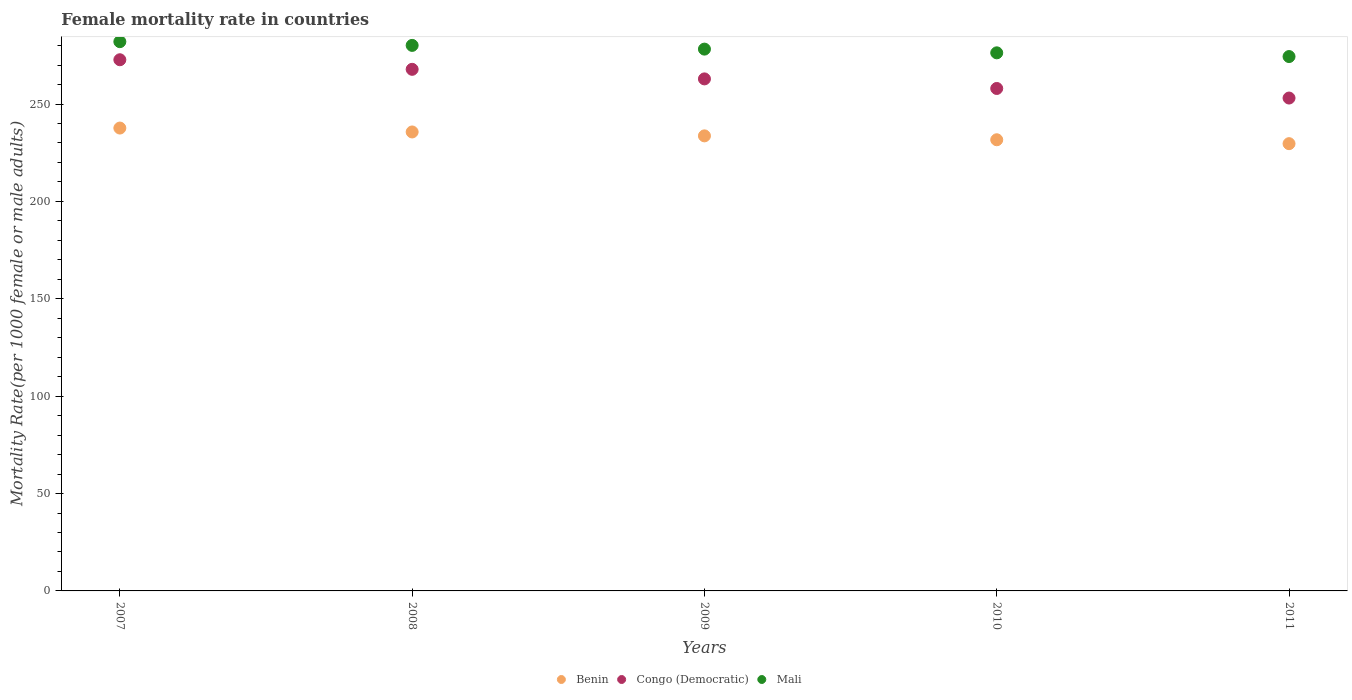How many different coloured dotlines are there?
Your answer should be compact. 3. Is the number of dotlines equal to the number of legend labels?
Keep it short and to the point. Yes. What is the female mortality rate in Congo (Democratic) in 2010?
Offer a terse response. 257.97. Across all years, what is the maximum female mortality rate in Congo (Democratic)?
Ensure brevity in your answer.  272.72. Across all years, what is the minimum female mortality rate in Benin?
Offer a very short reply. 229.63. In which year was the female mortality rate in Benin maximum?
Make the answer very short. 2007. What is the total female mortality rate in Mali in the graph?
Offer a very short reply. 1390.9. What is the difference between the female mortality rate in Mali in 2008 and that in 2009?
Offer a very short reply. 1.91. What is the difference between the female mortality rate in Benin in 2011 and the female mortality rate in Congo (Democratic) in 2008?
Offer a terse response. -38.17. What is the average female mortality rate in Congo (Democratic) per year?
Provide a short and direct response. 262.89. In the year 2011, what is the difference between the female mortality rate in Benin and female mortality rate in Congo (Democratic)?
Your response must be concise. -23.42. In how many years, is the female mortality rate in Congo (Democratic) greater than 20?
Your response must be concise. 5. What is the ratio of the female mortality rate in Mali in 2007 to that in 2011?
Ensure brevity in your answer.  1.03. Is the female mortality rate in Mali in 2007 less than that in 2009?
Keep it short and to the point. No. What is the difference between the highest and the second highest female mortality rate in Congo (Democratic)?
Give a very brief answer. 4.92. What is the difference between the highest and the lowest female mortality rate in Mali?
Provide a succinct answer. 7.64. In how many years, is the female mortality rate in Benin greater than the average female mortality rate in Benin taken over all years?
Ensure brevity in your answer.  2. Is it the case that in every year, the sum of the female mortality rate in Congo (Democratic) and female mortality rate in Mali  is greater than the female mortality rate in Benin?
Give a very brief answer. Yes. Does the female mortality rate in Mali monotonically increase over the years?
Your answer should be very brief. No. Is the female mortality rate in Congo (Democratic) strictly less than the female mortality rate in Benin over the years?
Ensure brevity in your answer.  No. How many dotlines are there?
Your answer should be very brief. 3. How many years are there in the graph?
Your response must be concise. 5. Does the graph contain grids?
Ensure brevity in your answer.  No. Where does the legend appear in the graph?
Make the answer very short. Bottom center. How are the legend labels stacked?
Your answer should be compact. Horizontal. What is the title of the graph?
Your answer should be compact. Female mortality rate in countries. Does "Zimbabwe" appear as one of the legend labels in the graph?
Keep it short and to the point. No. What is the label or title of the X-axis?
Provide a short and direct response. Years. What is the label or title of the Y-axis?
Provide a succinct answer. Mortality Rate(per 1000 female or male adults). What is the Mortality Rate(per 1000 female or male adults) in Benin in 2007?
Keep it short and to the point. 237.65. What is the Mortality Rate(per 1000 female or male adults) of Congo (Democratic) in 2007?
Provide a succinct answer. 272.72. What is the Mortality Rate(per 1000 female or male adults) of Mali in 2007?
Provide a succinct answer. 282. What is the Mortality Rate(per 1000 female or male adults) in Benin in 2008?
Keep it short and to the point. 235.64. What is the Mortality Rate(per 1000 female or male adults) of Congo (Democratic) in 2008?
Your answer should be compact. 267.8. What is the Mortality Rate(per 1000 female or male adults) of Mali in 2008?
Your response must be concise. 280.09. What is the Mortality Rate(per 1000 female or male adults) in Benin in 2009?
Ensure brevity in your answer.  233.64. What is the Mortality Rate(per 1000 female or male adults) in Congo (Democratic) in 2009?
Make the answer very short. 262.89. What is the Mortality Rate(per 1000 female or male adults) of Mali in 2009?
Your answer should be very brief. 278.18. What is the Mortality Rate(per 1000 female or male adults) of Benin in 2010?
Your answer should be compact. 231.64. What is the Mortality Rate(per 1000 female or male adults) of Congo (Democratic) in 2010?
Make the answer very short. 257.97. What is the Mortality Rate(per 1000 female or male adults) of Mali in 2010?
Provide a succinct answer. 276.27. What is the Mortality Rate(per 1000 female or male adults) in Benin in 2011?
Your answer should be very brief. 229.63. What is the Mortality Rate(per 1000 female or male adults) in Congo (Democratic) in 2011?
Keep it short and to the point. 253.06. What is the Mortality Rate(per 1000 female or male adults) in Mali in 2011?
Your answer should be very brief. 274.36. Across all years, what is the maximum Mortality Rate(per 1000 female or male adults) in Benin?
Your answer should be very brief. 237.65. Across all years, what is the maximum Mortality Rate(per 1000 female or male adults) in Congo (Democratic)?
Your response must be concise. 272.72. Across all years, what is the maximum Mortality Rate(per 1000 female or male adults) of Mali?
Provide a succinct answer. 282. Across all years, what is the minimum Mortality Rate(per 1000 female or male adults) in Benin?
Make the answer very short. 229.63. Across all years, what is the minimum Mortality Rate(per 1000 female or male adults) of Congo (Democratic)?
Provide a short and direct response. 253.06. Across all years, what is the minimum Mortality Rate(per 1000 female or male adults) in Mali?
Provide a succinct answer. 274.36. What is the total Mortality Rate(per 1000 female or male adults) of Benin in the graph?
Your answer should be compact. 1168.21. What is the total Mortality Rate(per 1000 female or male adults) in Congo (Democratic) in the graph?
Your response must be concise. 1314.44. What is the total Mortality Rate(per 1000 female or male adults) of Mali in the graph?
Give a very brief answer. 1390.9. What is the difference between the Mortality Rate(per 1000 female or male adults) in Benin in 2007 and that in 2008?
Provide a short and direct response. 2. What is the difference between the Mortality Rate(per 1000 female or male adults) in Congo (Democratic) in 2007 and that in 2008?
Give a very brief answer. 4.92. What is the difference between the Mortality Rate(per 1000 female or male adults) in Mali in 2007 and that in 2008?
Offer a terse response. 1.91. What is the difference between the Mortality Rate(per 1000 female or male adults) in Benin in 2007 and that in 2009?
Provide a succinct answer. 4.01. What is the difference between the Mortality Rate(per 1000 female or male adults) of Congo (Democratic) in 2007 and that in 2009?
Ensure brevity in your answer.  9.83. What is the difference between the Mortality Rate(per 1000 female or male adults) in Mali in 2007 and that in 2009?
Your answer should be compact. 3.82. What is the difference between the Mortality Rate(per 1000 female or male adults) of Benin in 2007 and that in 2010?
Ensure brevity in your answer.  6.01. What is the difference between the Mortality Rate(per 1000 female or male adults) of Congo (Democratic) in 2007 and that in 2010?
Your answer should be compact. 14.75. What is the difference between the Mortality Rate(per 1000 female or male adults) of Mali in 2007 and that in 2010?
Your answer should be very brief. 5.73. What is the difference between the Mortality Rate(per 1000 female or male adults) of Benin in 2007 and that in 2011?
Your answer should be very brief. 8.01. What is the difference between the Mortality Rate(per 1000 female or male adults) in Congo (Democratic) in 2007 and that in 2011?
Ensure brevity in your answer.  19.66. What is the difference between the Mortality Rate(per 1000 female or male adults) of Mali in 2007 and that in 2011?
Ensure brevity in your answer.  7.64. What is the difference between the Mortality Rate(per 1000 female or male adults) in Benin in 2008 and that in 2009?
Make the answer very short. 2. What is the difference between the Mortality Rate(per 1000 female or male adults) in Congo (Democratic) in 2008 and that in 2009?
Provide a succinct answer. 4.92. What is the difference between the Mortality Rate(per 1000 female or male adults) in Mali in 2008 and that in 2009?
Keep it short and to the point. 1.91. What is the difference between the Mortality Rate(per 1000 female or male adults) of Benin in 2008 and that in 2010?
Give a very brief answer. 4.01. What is the difference between the Mortality Rate(per 1000 female or male adults) in Congo (Democratic) in 2008 and that in 2010?
Provide a short and direct response. 9.83. What is the difference between the Mortality Rate(per 1000 female or male adults) of Mali in 2008 and that in 2010?
Offer a terse response. 3.82. What is the difference between the Mortality Rate(per 1000 female or male adults) of Benin in 2008 and that in 2011?
Offer a very short reply. 6.01. What is the difference between the Mortality Rate(per 1000 female or male adults) of Congo (Democratic) in 2008 and that in 2011?
Your answer should be compact. 14.75. What is the difference between the Mortality Rate(per 1000 female or male adults) in Mali in 2008 and that in 2011?
Offer a terse response. 5.73. What is the difference between the Mortality Rate(per 1000 female or male adults) of Benin in 2009 and that in 2010?
Make the answer very short. 2. What is the difference between the Mortality Rate(per 1000 female or male adults) in Congo (Democratic) in 2009 and that in 2010?
Provide a succinct answer. 4.92. What is the difference between the Mortality Rate(per 1000 female or male adults) in Mali in 2009 and that in 2010?
Your response must be concise. 1.91. What is the difference between the Mortality Rate(per 1000 female or male adults) in Benin in 2009 and that in 2011?
Make the answer very short. 4.01. What is the difference between the Mortality Rate(per 1000 female or male adults) of Congo (Democratic) in 2009 and that in 2011?
Your response must be concise. 9.83. What is the difference between the Mortality Rate(per 1000 female or male adults) in Mali in 2009 and that in 2011?
Your response must be concise. 3.82. What is the difference between the Mortality Rate(per 1000 female or male adults) in Benin in 2010 and that in 2011?
Keep it short and to the point. 2. What is the difference between the Mortality Rate(per 1000 female or male adults) in Congo (Democratic) in 2010 and that in 2011?
Offer a terse response. 4.92. What is the difference between the Mortality Rate(per 1000 female or male adults) of Mali in 2010 and that in 2011?
Offer a very short reply. 1.91. What is the difference between the Mortality Rate(per 1000 female or male adults) in Benin in 2007 and the Mortality Rate(per 1000 female or male adults) in Congo (Democratic) in 2008?
Keep it short and to the point. -30.16. What is the difference between the Mortality Rate(per 1000 female or male adults) of Benin in 2007 and the Mortality Rate(per 1000 female or male adults) of Mali in 2008?
Provide a short and direct response. -42.44. What is the difference between the Mortality Rate(per 1000 female or male adults) in Congo (Democratic) in 2007 and the Mortality Rate(per 1000 female or male adults) in Mali in 2008?
Provide a succinct answer. -7.37. What is the difference between the Mortality Rate(per 1000 female or male adults) of Benin in 2007 and the Mortality Rate(per 1000 female or male adults) of Congo (Democratic) in 2009?
Offer a very short reply. -25.24. What is the difference between the Mortality Rate(per 1000 female or male adults) in Benin in 2007 and the Mortality Rate(per 1000 female or male adults) in Mali in 2009?
Offer a terse response. -40.53. What is the difference between the Mortality Rate(per 1000 female or male adults) in Congo (Democratic) in 2007 and the Mortality Rate(per 1000 female or male adults) in Mali in 2009?
Provide a succinct answer. -5.46. What is the difference between the Mortality Rate(per 1000 female or male adults) in Benin in 2007 and the Mortality Rate(per 1000 female or male adults) in Congo (Democratic) in 2010?
Give a very brief answer. -20.32. What is the difference between the Mortality Rate(per 1000 female or male adults) in Benin in 2007 and the Mortality Rate(per 1000 female or male adults) in Mali in 2010?
Offer a very short reply. -38.62. What is the difference between the Mortality Rate(per 1000 female or male adults) of Congo (Democratic) in 2007 and the Mortality Rate(per 1000 female or male adults) of Mali in 2010?
Your answer should be compact. -3.55. What is the difference between the Mortality Rate(per 1000 female or male adults) of Benin in 2007 and the Mortality Rate(per 1000 female or male adults) of Congo (Democratic) in 2011?
Your answer should be very brief. -15.41. What is the difference between the Mortality Rate(per 1000 female or male adults) of Benin in 2007 and the Mortality Rate(per 1000 female or male adults) of Mali in 2011?
Keep it short and to the point. -36.71. What is the difference between the Mortality Rate(per 1000 female or male adults) of Congo (Democratic) in 2007 and the Mortality Rate(per 1000 female or male adults) of Mali in 2011?
Ensure brevity in your answer.  -1.64. What is the difference between the Mortality Rate(per 1000 female or male adults) in Benin in 2008 and the Mortality Rate(per 1000 female or male adults) in Congo (Democratic) in 2009?
Give a very brief answer. -27.25. What is the difference between the Mortality Rate(per 1000 female or male adults) in Benin in 2008 and the Mortality Rate(per 1000 female or male adults) in Mali in 2009?
Provide a short and direct response. -42.54. What is the difference between the Mortality Rate(per 1000 female or male adults) in Congo (Democratic) in 2008 and the Mortality Rate(per 1000 female or male adults) in Mali in 2009?
Your response must be concise. -10.38. What is the difference between the Mortality Rate(per 1000 female or male adults) of Benin in 2008 and the Mortality Rate(per 1000 female or male adults) of Congo (Democratic) in 2010?
Offer a terse response. -22.33. What is the difference between the Mortality Rate(per 1000 female or male adults) in Benin in 2008 and the Mortality Rate(per 1000 female or male adults) in Mali in 2010?
Your answer should be very brief. -40.63. What is the difference between the Mortality Rate(per 1000 female or male adults) in Congo (Democratic) in 2008 and the Mortality Rate(per 1000 female or male adults) in Mali in 2010?
Provide a short and direct response. -8.47. What is the difference between the Mortality Rate(per 1000 female or male adults) of Benin in 2008 and the Mortality Rate(per 1000 female or male adults) of Congo (Democratic) in 2011?
Your response must be concise. -17.41. What is the difference between the Mortality Rate(per 1000 female or male adults) of Benin in 2008 and the Mortality Rate(per 1000 female or male adults) of Mali in 2011?
Offer a terse response. -38.72. What is the difference between the Mortality Rate(per 1000 female or male adults) of Congo (Democratic) in 2008 and the Mortality Rate(per 1000 female or male adults) of Mali in 2011?
Give a very brief answer. -6.56. What is the difference between the Mortality Rate(per 1000 female or male adults) of Benin in 2009 and the Mortality Rate(per 1000 female or male adults) of Congo (Democratic) in 2010?
Your answer should be very brief. -24.33. What is the difference between the Mortality Rate(per 1000 female or male adults) in Benin in 2009 and the Mortality Rate(per 1000 female or male adults) in Mali in 2010?
Ensure brevity in your answer.  -42.63. What is the difference between the Mortality Rate(per 1000 female or male adults) in Congo (Democratic) in 2009 and the Mortality Rate(per 1000 female or male adults) in Mali in 2010?
Offer a very short reply. -13.38. What is the difference between the Mortality Rate(per 1000 female or male adults) of Benin in 2009 and the Mortality Rate(per 1000 female or male adults) of Congo (Democratic) in 2011?
Ensure brevity in your answer.  -19.42. What is the difference between the Mortality Rate(per 1000 female or male adults) in Benin in 2009 and the Mortality Rate(per 1000 female or male adults) in Mali in 2011?
Your answer should be very brief. -40.72. What is the difference between the Mortality Rate(per 1000 female or male adults) of Congo (Democratic) in 2009 and the Mortality Rate(per 1000 female or male adults) of Mali in 2011?
Your answer should be compact. -11.47. What is the difference between the Mortality Rate(per 1000 female or male adults) of Benin in 2010 and the Mortality Rate(per 1000 female or male adults) of Congo (Democratic) in 2011?
Offer a terse response. -21.42. What is the difference between the Mortality Rate(per 1000 female or male adults) in Benin in 2010 and the Mortality Rate(per 1000 female or male adults) in Mali in 2011?
Provide a succinct answer. -42.72. What is the difference between the Mortality Rate(per 1000 female or male adults) in Congo (Democratic) in 2010 and the Mortality Rate(per 1000 female or male adults) in Mali in 2011?
Your response must be concise. -16.39. What is the average Mortality Rate(per 1000 female or male adults) in Benin per year?
Your answer should be very brief. 233.64. What is the average Mortality Rate(per 1000 female or male adults) in Congo (Democratic) per year?
Keep it short and to the point. 262.89. What is the average Mortality Rate(per 1000 female or male adults) in Mali per year?
Offer a terse response. 278.18. In the year 2007, what is the difference between the Mortality Rate(per 1000 female or male adults) in Benin and Mortality Rate(per 1000 female or male adults) in Congo (Democratic)?
Your response must be concise. -35.07. In the year 2007, what is the difference between the Mortality Rate(per 1000 female or male adults) in Benin and Mortality Rate(per 1000 female or male adults) in Mali?
Your answer should be compact. -44.35. In the year 2007, what is the difference between the Mortality Rate(per 1000 female or male adults) of Congo (Democratic) and Mortality Rate(per 1000 female or male adults) of Mali?
Offer a terse response. -9.28. In the year 2008, what is the difference between the Mortality Rate(per 1000 female or male adults) in Benin and Mortality Rate(per 1000 female or male adults) in Congo (Democratic)?
Offer a very short reply. -32.16. In the year 2008, what is the difference between the Mortality Rate(per 1000 female or male adults) of Benin and Mortality Rate(per 1000 female or male adults) of Mali?
Make the answer very short. -44.45. In the year 2008, what is the difference between the Mortality Rate(per 1000 female or male adults) of Congo (Democratic) and Mortality Rate(per 1000 female or male adults) of Mali?
Your response must be concise. -12.29. In the year 2009, what is the difference between the Mortality Rate(per 1000 female or male adults) of Benin and Mortality Rate(per 1000 female or male adults) of Congo (Democratic)?
Your response must be concise. -29.25. In the year 2009, what is the difference between the Mortality Rate(per 1000 female or male adults) of Benin and Mortality Rate(per 1000 female or male adults) of Mali?
Ensure brevity in your answer.  -44.54. In the year 2009, what is the difference between the Mortality Rate(per 1000 female or male adults) of Congo (Democratic) and Mortality Rate(per 1000 female or male adults) of Mali?
Offer a very short reply. -15.29. In the year 2010, what is the difference between the Mortality Rate(per 1000 female or male adults) in Benin and Mortality Rate(per 1000 female or male adults) in Congo (Democratic)?
Keep it short and to the point. -26.34. In the year 2010, what is the difference between the Mortality Rate(per 1000 female or male adults) of Benin and Mortality Rate(per 1000 female or male adults) of Mali?
Your response must be concise. -44.63. In the year 2010, what is the difference between the Mortality Rate(per 1000 female or male adults) of Congo (Democratic) and Mortality Rate(per 1000 female or male adults) of Mali?
Offer a very short reply. -18.3. In the year 2011, what is the difference between the Mortality Rate(per 1000 female or male adults) of Benin and Mortality Rate(per 1000 female or male adults) of Congo (Democratic)?
Give a very brief answer. -23.42. In the year 2011, what is the difference between the Mortality Rate(per 1000 female or male adults) of Benin and Mortality Rate(per 1000 female or male adults) of Mali?
Your answer should be very brief. -44.73. In the year 2011, what is the difference between the Mortality Rate(per 1000 female or male adults) in Congo (Democratic) and Mortality Rate(per 1000 female or male adults) in Mali?
Provide a succinct answer. -21.3. What is the ratio of the Mortality Rate(per 1000 female or male adults) of Benin in 2007 to that in 2008?
Give a very brief answer. 1.01. What is the ratio of the Mortality Rate(per 1000 female or male adults) in Congo (Democratic) in 2007 to that in 2008?
Offer a terse response. 1.02. What is the ratio of the Mortality Rate(per 1000 female or male adults) of Mali in 2007 to that in 2008?
Offer a very short reply. 1.01. What is the ratio of the Mortality Rate(per 1000 female or male adults) of Benin in 2007 to that in 2009?
Give a very brief answer. 1.02. What is the ratio of the Mortality Rate(per 1000 female or male adults) in Congo (Democratic) in 2007 to that in 2009?
Your response must be concise. 1.04. What is the ratio of the Mortality Rate(per 1000 female or male adults) in Mali in 2007 to that in 2009?
Provide a short and direct response. 1.01. What is the ratio of the Mortality Rate(per 1000 female or male adults) in Benin in 2007 to that in 2010?
Your answer should be compact. 1.03. What is the ratio of the Mortality Rate(per 1000 female or male adults) of Congo (Democratic) in 2007 to that in 2010?
Ensure brevity in your answer.  1.06. What is the ratio of the Mortality Rate(per 1000 female or male adults) of Mali in 2007 to that in 2010?
Make the answer very short. 1.02. What is the ratio of the Mortality Rate(per 1000 female or male adults) of Benin in 2007 to that in 2011?
Offer a terse response. 1.03. What is the ratio of the Mortality Rate(per 1000 female or male adults) in Congo (Democratic) in 2007 to that in 2011?
Make the answer very short. 1.08. What is the ratio of the Mortality Rate(per 1000 female or male adults) of Mali in 2007 to that in 2011?
Provide a short and direct response. 1.03. What is the ratio of the Mortality Rate(per 1000 female or male adults) in Benin in 2008 to that in 2009?
Offer a very short reply. 1.01. What is the ratio of the Mortality Rate(per 1000 female or male adults) of Congo (Democratic) in 2008 to that in 2009?
Keep it short and to the point. 1.02. What is the ratio of the Mortality Rate(per 1000 female or male adults) of Mali in 2008 to that in 2009?
Make the answer very short. 1.01. What is the ratio of the Mortality Rate(per 1000 female or male adults) in Benin in 2008 to that in 2010?
Provide a succinct answer. 1.02. What is the ratio of the Mortality Rate(per 1000 female or male adults) in Congo (Democratic) in 2008 to that in 2010?
Ensure brevity in your answer.  1.04. What is the ratio of the Mortality Rate(per 1000 female or male adults) in Mali in 2008 to that in 2010?
Ensure brevity in your answer.  1.01. What is the ratio of the Mortality Rate(per 1000 female or male adults) in Benin in 2008 to that in 2011?
Offer a terse response. 1.03. What is the ratio of the Mortality Rate(per 1000 female or male adults) in Congo (Democratic) in 2008 to that in 2011?
Offer a terse response. 1.06. What is the ratio of the Mortality Rate(per 1000 female or male adults) in Mali in 2008 to that in 2011?
Give a very brief answer. 1.02. What is the ratio of the Mortality Rate(per 1000 female or male adults) in Benin in 2009 to that in 2010?
Keep it short and to the point. 1.01. What is the ratio of the Mortality Rate(per 1000 female or male adults) in Congo (Democratic) in 2009 to that in 2010?
Make the answer very short. 1.02. What is the ratio of the Mortality Rate(per 1000 female or male adults) in Mali in 2009 to that in 2010?
Keep it short and to the point. 1.01. What is the ratio of the Mortality Rate(per 1000 female or male adults) in Benin in 2009 to that in 2011?
Your answer should be very brief. 1.02. What is the ratio of the Mortality Rate(per 1000 female or male adults) of Congo (Democratic) in 2009 to that in 2011?
Your answer should be compact. 1.04. What is the ratio of the Mortality Rate(per 1000 female or male adults) in Mali in 2009 to that in 2011?
Your answer should be very brief. 1.01. What is the ratio of the Mortality Rate(per 1000 female or male adults) of Benin in 2010 to that in 2011?
Your response must be concise. 1.01. What is the ratio of the Mortality Rate(per 1000 female or male adults) in Congo (Democratic) in 2010 to that in 2011?
Offer a very short reply. 1.02. What is the ratio of the Mortality Rate(per 1000 female or male adults) of Mali in 2010 to that in 2011?
Your answer should be very brief. 1.01. What is the difference between the highest and the second highest Mortality Rate(per 1000 female or male adults) of Benin?
Ensure brevity in your answer.  2. What is the difference between the highest and the second highest Mortality Rate(per 1000 female or male adults) of Congo (Democratic)?
Offer a very short reply. 4.92. What is the difference between the highest and the second highest Mortality Rate(per 1000 female or male adults) of Mali?
Ensure brevity in your answer.  1.91. What is the difference between the highest and the lowest Mortality Rate(per 1000 female or male adults) of Benin?
Keep it short and to the point. 8.01. What is the difference between the highest and the lowest Mortality Rate(per 1000 female or male adults) in Congo (Democratic)?
Your response must be concise. 19.66. What is the difference between the highest and the lowest Mortality Rate(per 1000 female or male adults) in Mali?
Make the answer very short. 7.64. 